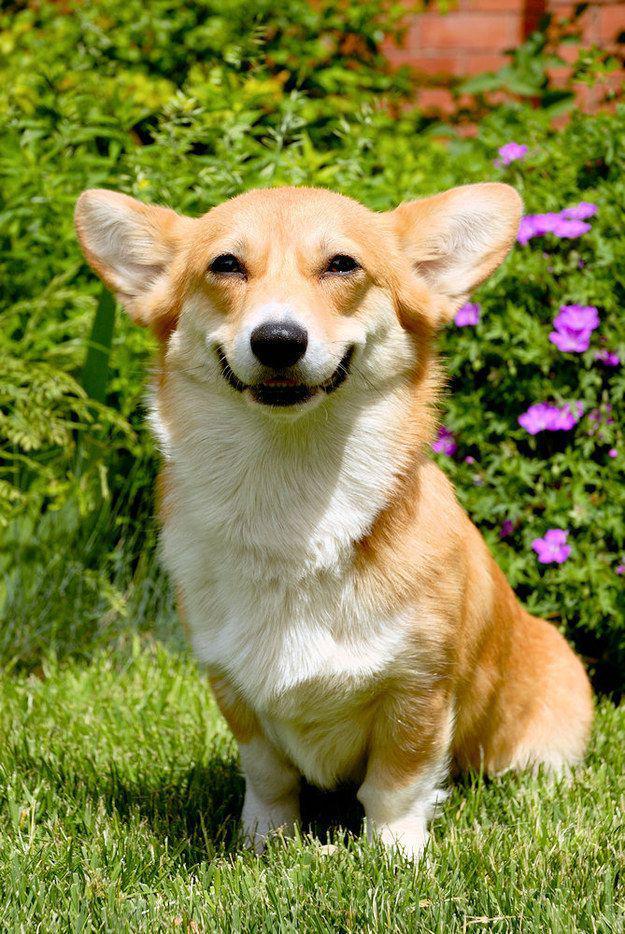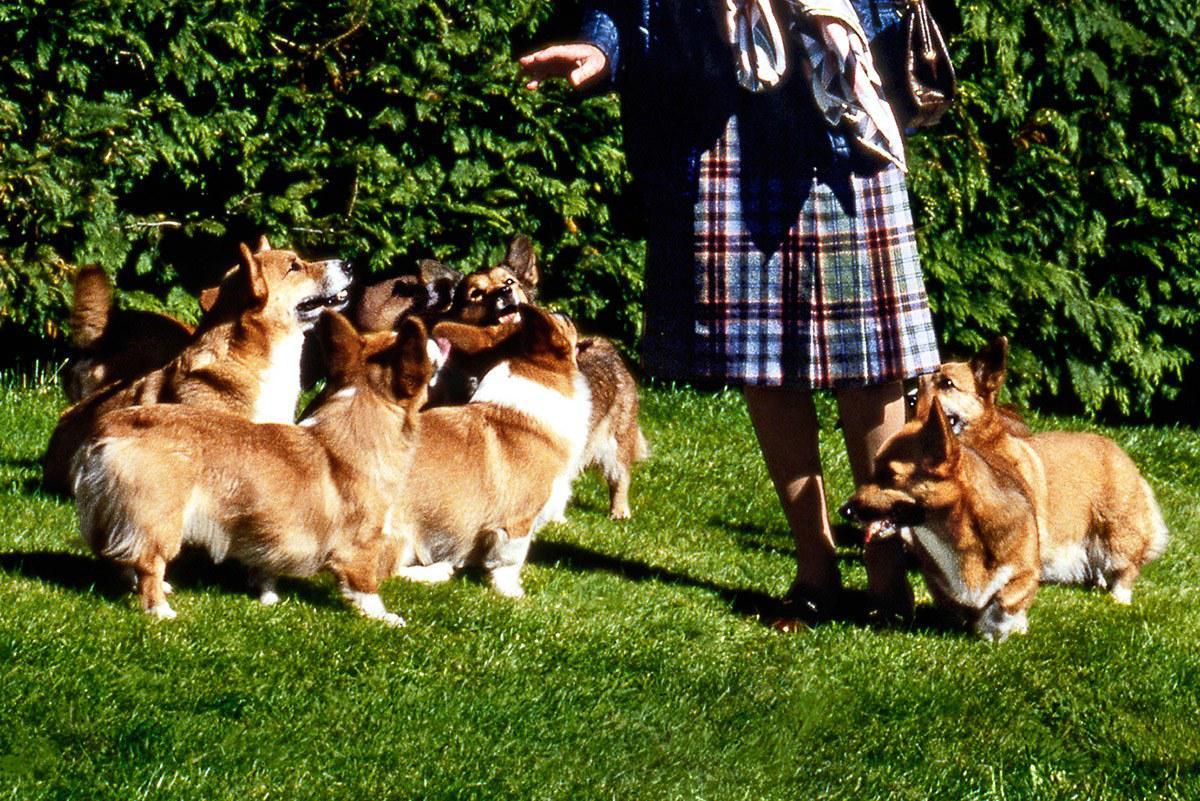The first image is the image on the left, the second image is the image on the right. For the images displayed, is the sentence "There are exactly 3 dogs, and they are all outside." factually correct? Answer yes or no. No. 